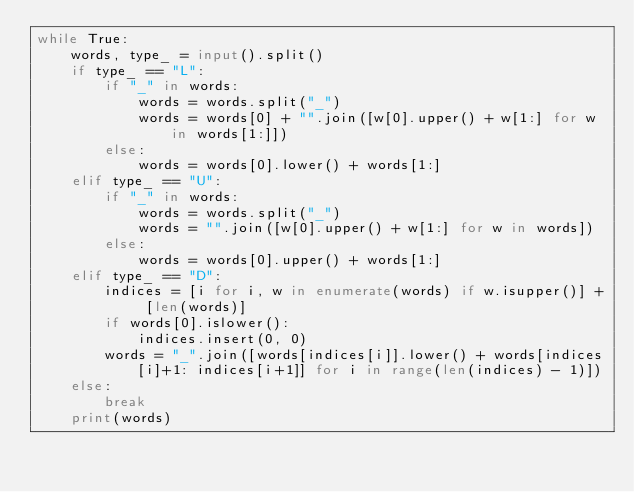<code> <loc_0><loc_0><loc_500><loc_500><_Python_>while True:
    words, type_ = input().split()
    if type_ == "L":
        if "_" in words:
            words = words.split("_")
            words = words[0] + "".join([w[0].upper() + w[1:] for w in words[1:]])
        else:
            words = words[0].lower() + words[1:]
    elif type_ == "U":
        if "_" in words:
            words = words.split("_")
            words = "".join([w[0].upper() + w[1:] for w in words])
        else:
            words = words[0].upper() + words[1:]
    elif type_ == "D":
        indices = [i for i, w in enumerate(words) if w.isupper()] + [len(words)]
        if words[0].islower():
            indices.insert(0, 0)
        words = "_".join([words[indices[i]].lower() + words[indices[i]+1: indices[i+1]] for i in range(len(indices) - 1)])
    else:
        break
    print(words)</code> 